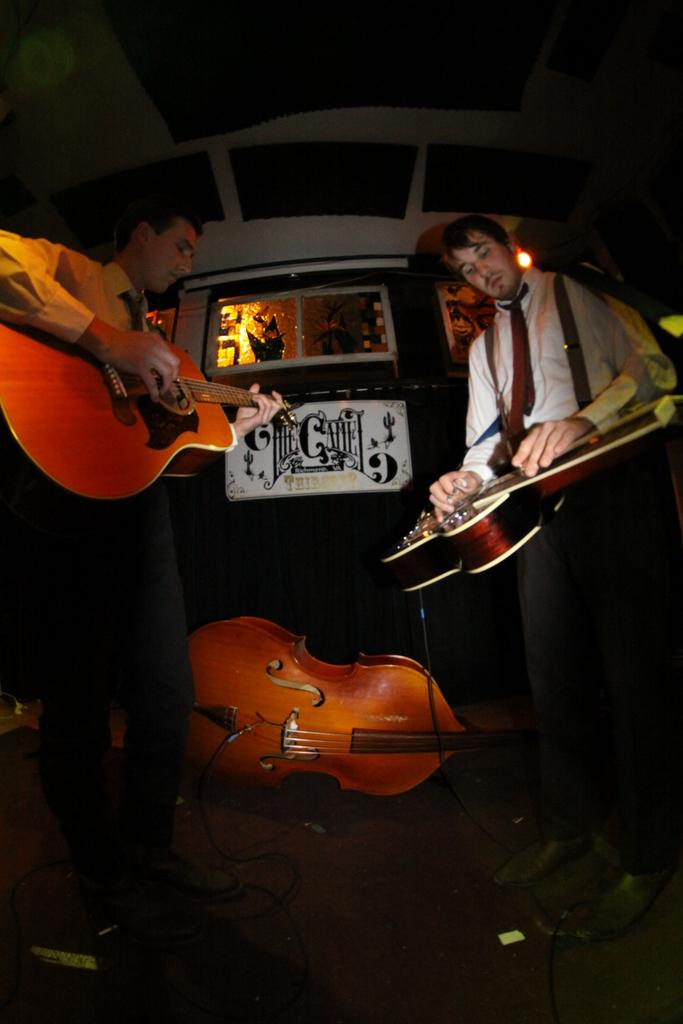How many persons are in the image? There are two persons in the image. What are the persons doing in the image? The persons are standing and holding guitars. Can you describe the main object in the center of the image? There is a guitar in the center of the image. What can be seen in the background of the image? There is a wall, a light, a window, a banner, and wires in the background of the image. What type of friction can be observed between the persons and their guitars in the image? There is no indication of friction between the persons and their guitars in the image. Is there a crown visible on the head of one of the persons in the image? No, there is no crown present on the head of either person in the image. 